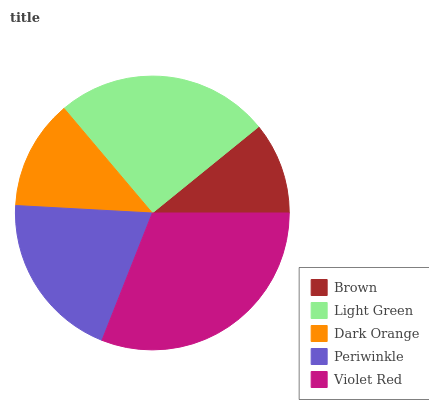Is Brown the minimum?
Answer yes or no. Yes. Is Violet Red the maximum?
Answer yes or no. Yes. Is Light Green the minimum?
Answer yes or no. No. Is Light Green the maximum?
Answer yes or no. No. Is Light Green greater than Brown?
Answer yes or no. Yes. Is Brown less than Light Green?
Answer yes or no. Yes. Is Brown greater than Light Green?
Answer yes or no. No. Is Light Green less than Brown?
Answer yes or no. No. Is Periwinkle the high median?
Answer yes or no. Yes. Is Periwinkle the low median?
Answer yes or no. Yes. Is Violet Red the high median?
Answer yes or no. No. Is Violet Red the low median?
Answer yes or no. No. 